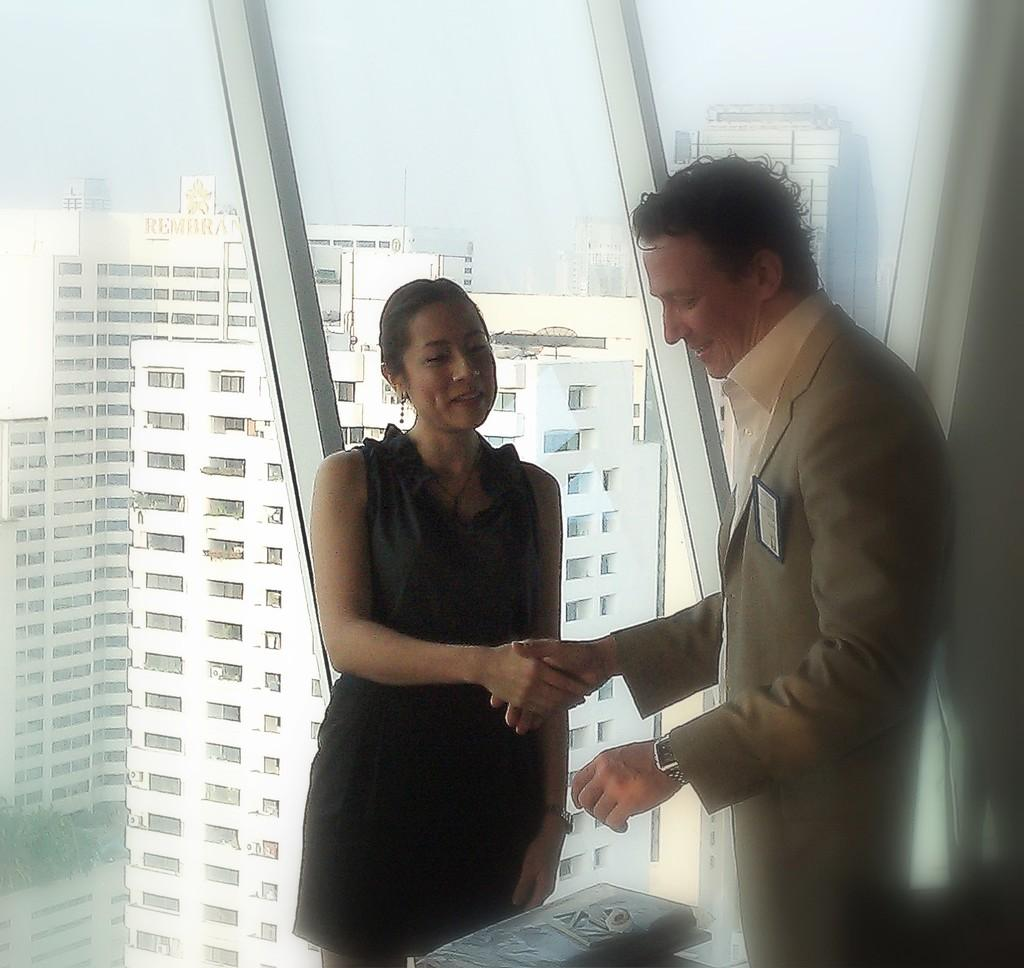How many people are in the image? There are two people in the image. What are the people doing in the image? The people are standing and smiling, and they are shaking hands. What can be seen through the glass in the image? Buildings and the sky are visible through the glass. What object is present in the image? There is a glass in the image. What type of celery is being used for teaching in the image? There is no celery present in the image, and no teaching is taking place. 